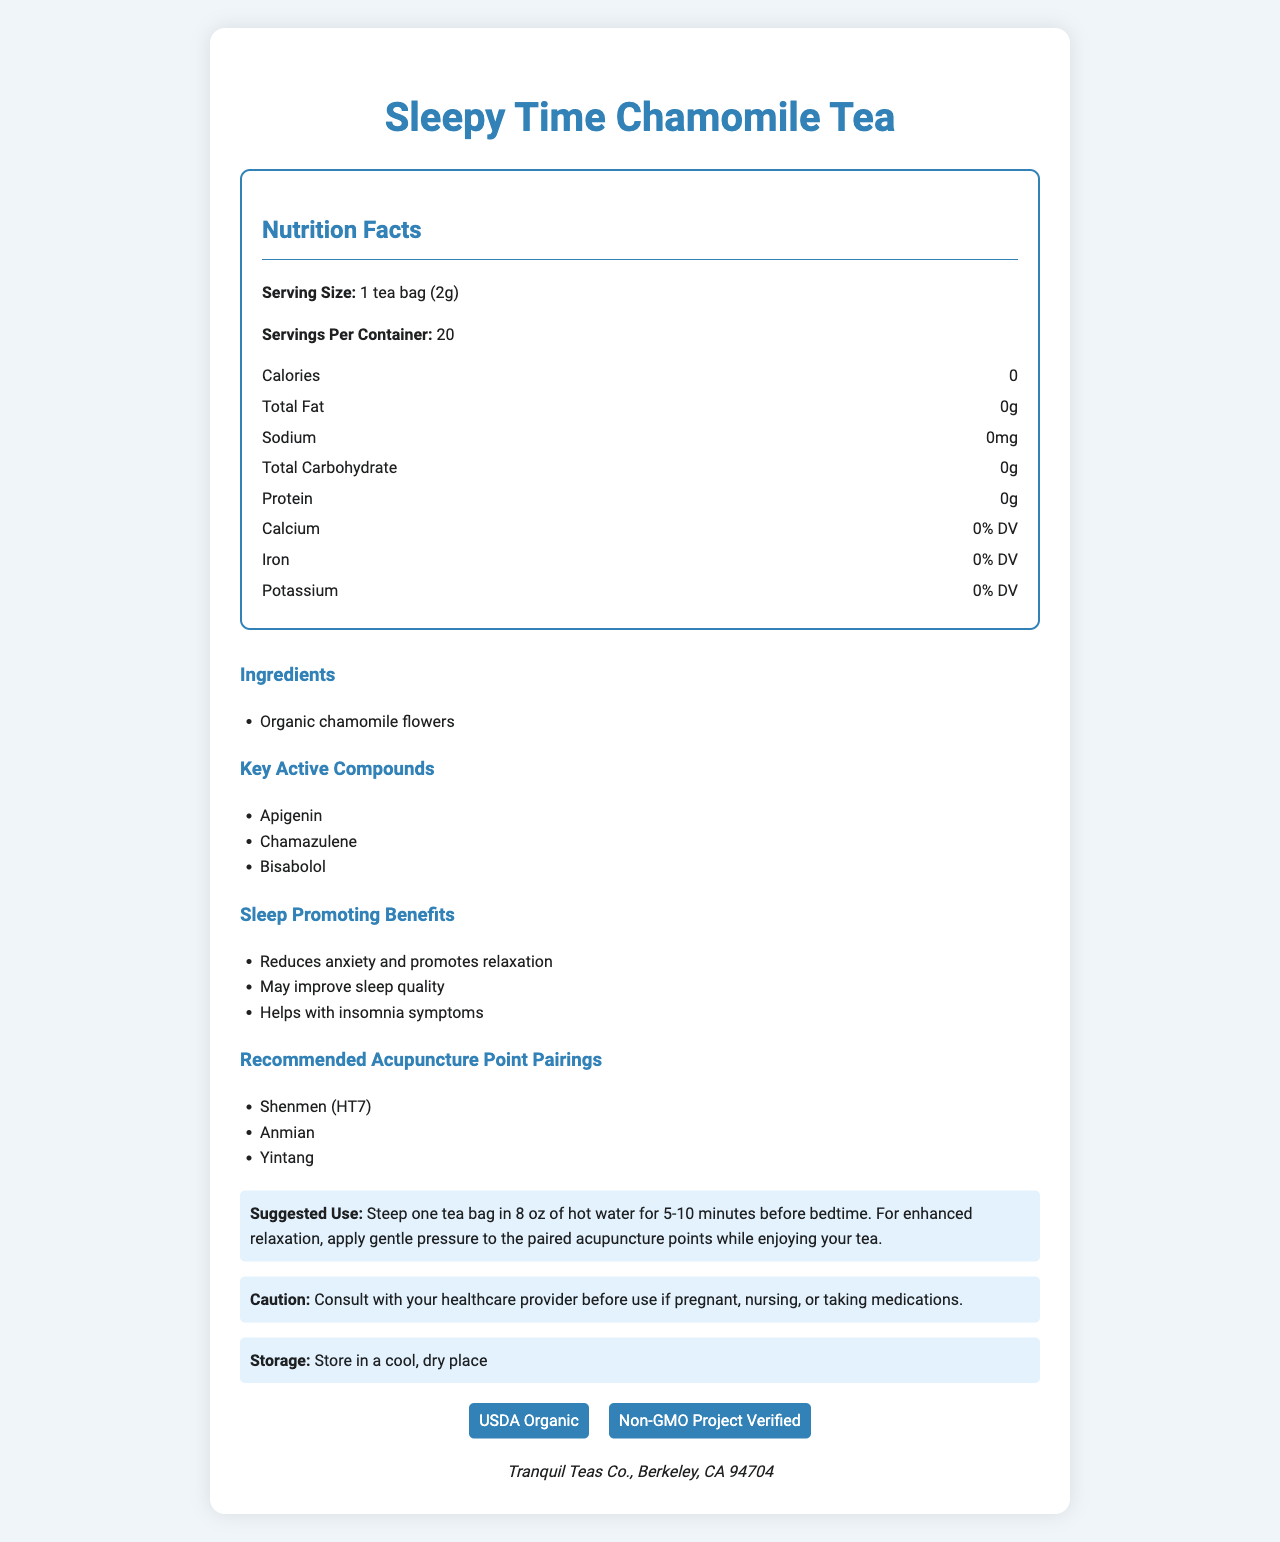what is the serving size for Sleepy Time Chamomile Tea? The serving size is clearly listed in the document under the Nutrition Facts section.
Answer: 1 tea bag (2g) how many calories are in one serving of this tea? The document states that there are 0 calories in one serving under the Nutrition Facts section.
Answer: 0 what are the key active compounds found in this tea? The document lists these compounds under the Key Active Compounds section.
Answer: Apigenin, Chamazulene, Bisabolol what benefits does the Sleepy Time Chamomile Tea provide for sleep? The document lists these benefits under the Sleep Promoting Benefits section.
Answer: Reduces anxiety and promotes relaxation, May improve sleep quality, Helps with insomnia symptoms how should you prepare Sleepy Time Chamomile Tea for optimal results? The document provides this information under the Suggested Use section.
Answer: Steep one tea bag in 8 oz of hot water for 5-10 minutes before bedtime and apply gentle pressure to the paired acupuncture points while enjoying your tea. how many servings does one container of Sleepy Time Chamomile Tea provide? A. 15 B. 20 C. 25 According to the document, there are 20 servings per container under the Nutrition Facts section.
Answer: B which of the following is NOT listed as an active compound in Sleepy Time Chamomile Tea? i. Apigenin ii. Bisabolol iii. Theobromine iv. Chamazulene The active compounds listed in the document are Apigenin, Bisabolol, and Chamazulene. Theobromine is not mentioned.
Answer: iii is this tea recommended for people who are pregnant or nursing? The document includes a caution that advises consultation with a healthcare provider under the Caution section.
Answer: No, consult with your healthcare provider before use if pregnant, nursing, or taking medications. summarize the main idea of the Sleepy Time Chamomile Tea Nutrition Facts Label. The document comprehensively shows the nutritional information, benefits, ingredients, suggested use, and certifications of Sleepy Time Chamomile Tea.
Answer: Sleepy Time Chamomile Tea is a calming, zero-calorie tea designed to promote relaxation and improve sleep quality. It contains organic chamomile flowers and key active compounds like Apigenin, Chamazulene, and Bisabolol, which help reduce anxiety, improve sleep quality, and address insomnia symptoms. The label also provides information on serving size, preparation instructions, recommended acupuncture points, and certifications such as USDA Organic and Non-GMO Project Verified. what is the calcium content per serving in terms of Daily Value (DV)? The document lists calcium content as 0% DV in the Nutrition Facts section.
Answer: 0% DV who is the manufacturer of Sleepy Time Chamomile Tea? The document lists the manufacturer at the bottom.
Answer: Tranquil Teas Co., Berkeley, CA 94704 can the exact amount of Apigenin, Chamazulene, and Bisabolol be determined from this document? The document lists the active compounds but does not specify their exact quantities.
Answer: No, the exact amounts of these compounds are not provided. 